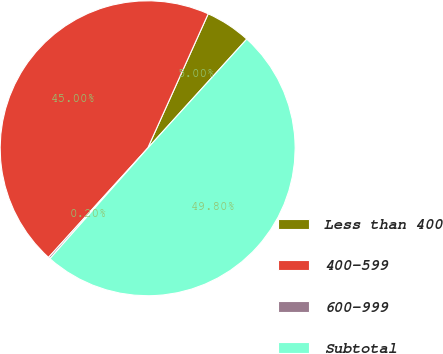Convert chart. <chart><loc_0><loc_0><loc_500><loc_500><pie_chart><fcel>Less than 400<fcel>400-599<fcel>600-999<fcel>Subtotal<nl><fcel>5.0%<fcel>45.0%<fcel>0.2%<fcel>49.8%<nl></chart> 